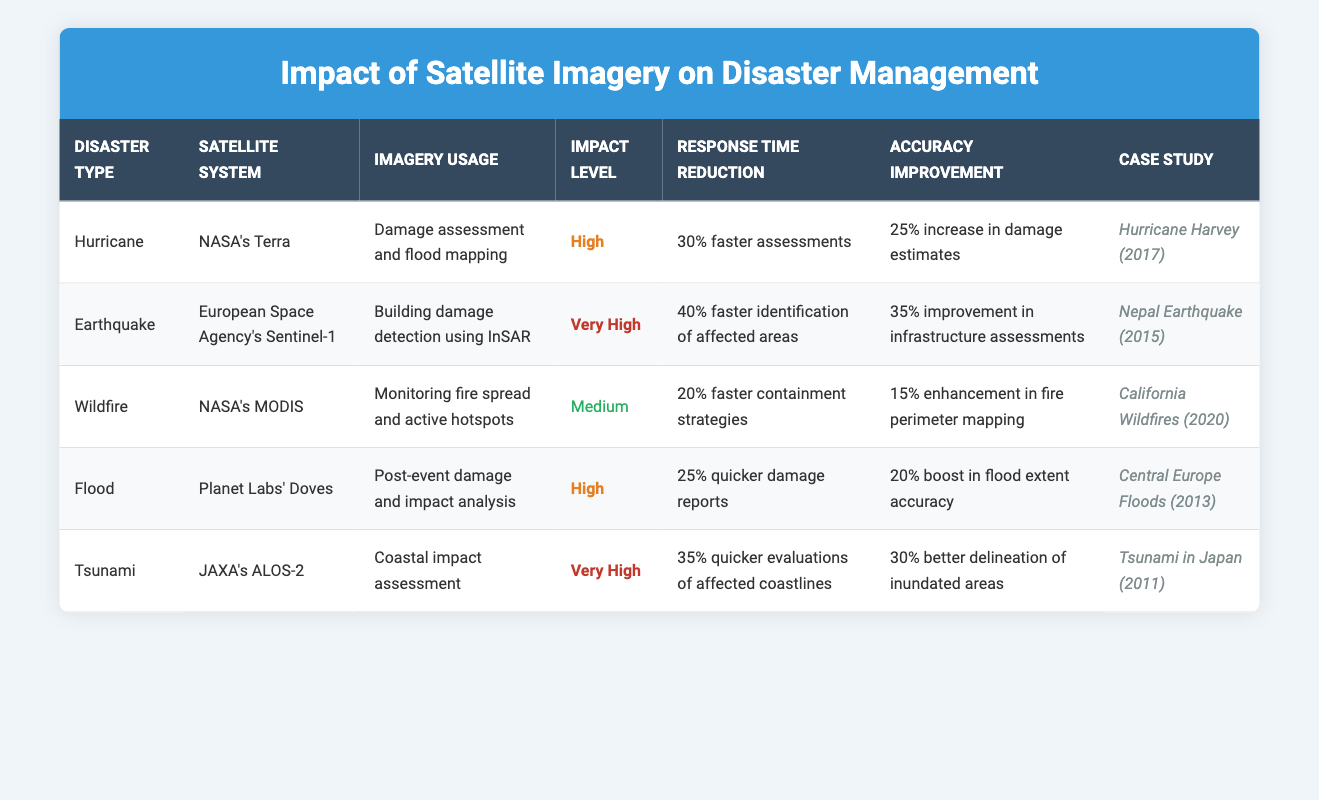What is the impact level of the satellite imagery used for monitoring California wildfires? The table shows that the impact level for NASA's MODIS, used for monitoring wildfires, is categorized as "Medium."
Answer: Medium Which satellite system had the highest accuracy improvement in damage assessments? Looking at the table, ESA's Sentinel-1 shows a 35% improvement in infrastructure assessments, which is the highest among all the listed satellite systems.
Answer: ESA's Sentinel-1 Is the response time reduction for tsunami evaluations greater than for hurricane assessments? The response time reduction for tsunami evaluations (35% quicker) is higher than for hurricane assessments (30% faster), indicating that tsunami evaluations are indeed more efficient.
Answer: Yes What is the percentage increase in damage estimates for Hurricane assessments using NASA's Terra? The table indicates that using NASA's Terra for Hurricane damage assessment leads to a 25% increase in damage estimates. Thus, the said percentage is 25%.
Answer: 25% Compare the accuracy improvements of flood assessments and wildfire monitoring— which one has a larger percentage increase? The accuracy improvement for flood assessments (20% boost) is greater than that for wildfire monitoring (15% enhancement). Thus, flood assessments have a larger percentage.
Answer: Flood assessments How much faster are response times for earthquake damage assessments compared to wildfire containment strategies? The response time reduction for earthquake assessments (40% faster) compared to wildfire containment strategies (20% faster) is a difference of 20%. Therefore, earthquake assessments are 20% faster.
Answer: 20% True or False: The impact level for the satellite imagery used to assess the Central Europe Floods is classified as "Very High." Upon examining the table, the impact level for the satellite imagery used for Central Europe Floods is "High," therefore the statement is false.
Answer: False Which case study involved the use of JAXA's ALOS-2 satellite system? According to the table, the case study involving JAXA's ALOS-2 is the "Tsunami in Japan (2011)." Hence, the answer is Tsunami in Japan (2011).
Answer: Tsunami in Japan (2011) What is the average response time reduction across all listed disasters represented in the table? The response time reductions for the disasters are: 30%, 40%, 20%, 25%, and 35%. Adding these together gives 150%. Dividing by the number of disasters (5) results in an average reduction of 30%.
Answer: 30% 